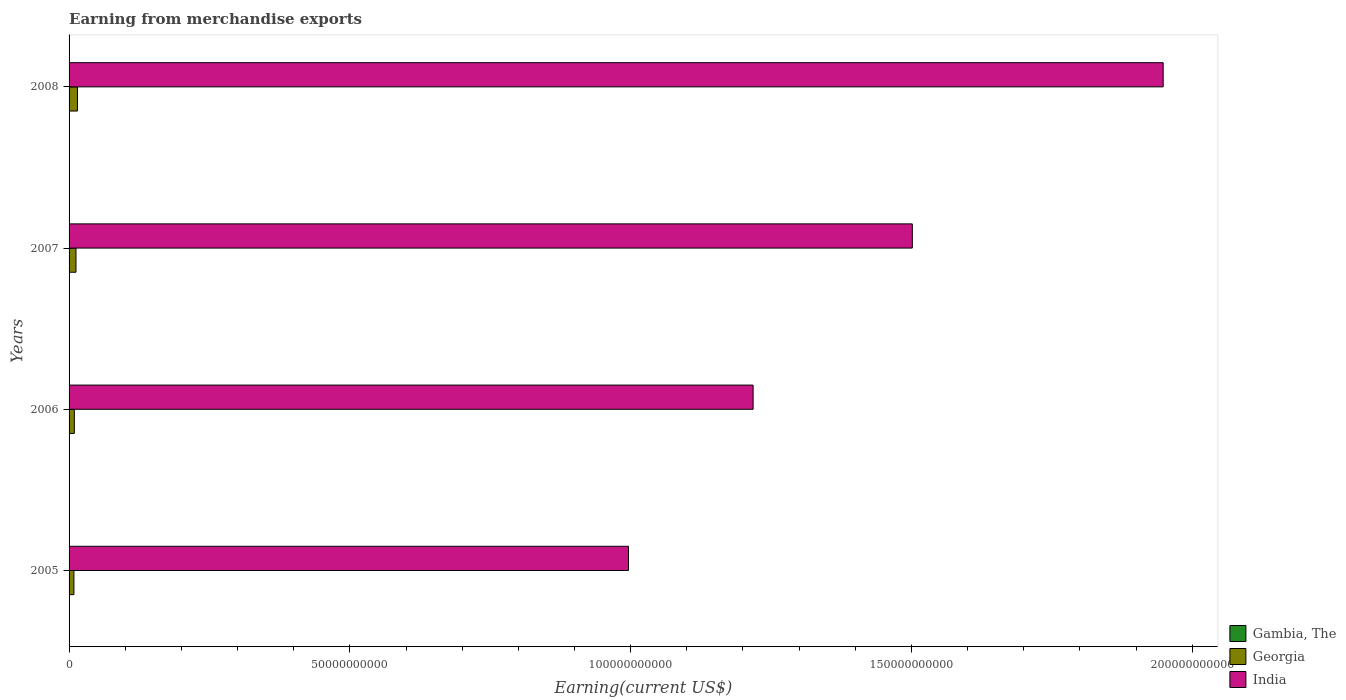Are the number of bars per tick equal to the number of legend labels?
Give a very brief answer. Yes. What is the label of the 1st group of bars from the top?
Ensure brevity in your answer.  2008. What is the amount earned from merchandise exports in India in 2006?
Provide a succinct answer. 1.22e+11. Across all years, what is the maximum amount earned from merchandise exports in Georgia?
Ensure brevity in your answer.  1.50e+09. Across all years, what is the minimum amount earned from merchandise exports in India?
Make the answer very short. 9.96e+1. What is the total amount earned from merchandise exports in Gambia, The in the graph?
Make the answer very short. 4.59e+07. What is the difference between the amount earned from merchandise exports in India in 2005 and that in 2007?
Your response must be concise. -5.05e+1. What is the difference between the amount earned from merchandise exports in Gambia, The in 2008 and the amount earned from merchandise exports in Georgia in 2007?
Make the answer very short. -1.22e+09. What is the average amount earned from merchandise exports in India per year?
Offer a very short reply. 1.42e+11. In the year 2008, what is the difference between the amount earned from merchandise exports in India and amount earned from merchandise exports in Gambia, The?
Offer a very short reply. 1.95e+11. In how many years, is the amount earned from merchandise exports in Georgia greater than 190000000000 US$?
Your response must be concise. 0. What is the ratio of the amount earned from merchandise exports in India in 2005 to that in 2007?
Keep it short and to the point. 0.66. What is the difference between the highest and the second highest amount earned from merchandise exports in Georgia?
Your answer should be compact. 2.63e+08. What is the difference between the highest and the lowest amount earned from merchandise exports in Gambia, The?
Ensure brevity in your answer.  6.21e+06. Is the sum of the amount earned from merchandise exports in India in 2007 and 2008 greater than the maximum amount earned from merchandise exports in Georgia across all years?
Offer a very short reply. Yes. What does the 3rd bar from the top in 2006 represents?
Your answer should be compact. Gambia, The. What does the 3rd bar from the bottom in 2005 represents?
Provide a succinct answer. India. How many bars are there?
Provide a succinct answer. 12. How many years are there in the graph?
Provide a succinct answer. 4. Are the values on the major ticks of X-axis written in scientific E-notation?
Make the answer very short. No. Where does the legend appear in the graph?
Ensure brevity in your answer.  Bottom right. How many legend labels are there?
Provide a succinct answer. 3. What is the title of the graph?
Keep it short and to the point. Earning from merchandise exports. What is the label or title of the X-axis?
Keep it short and to the point. Earning(current US$). What is the label or title of the Y-axis?
Give a very brief answer. Years. What is the Earning(current US$) of Gambia, The in 2005?
Your answer should be compact. 7.46e+06. What is the Earning(current US$) of Georgia in 2005?
Your answer should be compact. 8.65e+08. What is the Earning(current US$) of India in 2005?
Ensure brevity in your answer.  9.96e+1. What is the Earning(current US$) in Gambia, The in 2006?
Make the answer very short. 1.15e+07. What is the Earning(current US$) of Georgia in 2006?
Your answer should be compact. 9.36e+08. What is the Earning(current US$) in India in 2006?
Ensure brevity in your answer.  1.22e+11. What is the Earning(current US$) of Gambia, The in 2007?
Provide a succinct answer. 1.33e+07. What is the Earning(current US$) of Georgia in 2007?
Your answer should be very brief. 1.23e+09. What is the Earning(current US$) of India in 2007?
Your response must be concise. 1.50e+11. What is the Earning(current US$) of Gambia, The in 2008?
Make the answer very short. 1.37e+07. What is the Earning(current US$) in Georgia in 2008?
Offer a very short reply. 1.50e+09. What is the Earning(current US$) of India in 2008?
Offer a very short reply. 1.95e+11. Across all years, what is the maximum Earning(current US$) of Gambia, The?
Your response must be concise. 1.37e+07. Across all years, what is the maximum Earning(current US$) in Georgia?
Give a very brief answer. 1.50e+09. Across all years, what is the maximum Earning(current US$) in India?
Your answer should be compact. 1.95e+11. Across all years, what is the minimum Earning(current US$) in Gambia, The?
Your response must be concise. 7.46e+06. Across all years, what is the minimum Earning(current US$) of Georgia?
Make the answer very short. 8.65e+08. Across all years, what is the minimum Earning(current US$) of India?
Provide a short and direct response. 9.96e+1. What is the total Earning(current US$) of Gambia, The in the graph?
Keep it short and to the point. 4.59e+07. What is the total Earning(current US$) in Georgia in the graph?
Give a very brief answer. 4.53e+09. What is the total Earning(current US$) of India in the graph?
Your answer should be very brief. 5.66e+11. What is the difference between the Earning(current US$) in Gambia, The in 2005 and that in 2006?
Your answer should be compact. -4.00e+06. What is the difference between the Earning(current US$) in Georgia in 2005 and that in 2006?
Ensure brevity in your answer.  -7.12e+07. What is the difference between the Earning(current US$) of India in 2005 and that in 2006?
Your answer should be compact. -2.22e+1. What is the difference between the Earning(current US$) of Gambia, The in 2005 and that in 2007?
Make the answer very short. -5.87e+06. What is the difference between the Earning(current US$) in Georgia in 2005 and that in 2007?
Provide a succinct answer. -3.67e+08. What is the difference between the Earning(current US$) of India in 2005 and that in 2007?
Your response must be concise. -5.05e+1. What is the difference between the Earning(current US$) in Gambia, The in 2005 and that in 2008?
Keep it short and to the point. -6.21e+06. What is the difference between the Earning(current US$) in Georgia in 2005 and that in 2008?
Keep it short and to the point. -6.30e+08. What is the difference between the Earning(current US$) of India in 2005 and that in 2008?
Ensure brevity in your answer.  -9.52e+1. What is the difference between the Earning(current US$) of Gambia, The in 2006 and that in 2007?
Make the answer very short. -1.87e+06. What is the difference between the Earning(current US$) of Georgia in 2006 and that in 2007?
Your response must be concise. -2.96e+08. What is the difference between the Earning(current US$) of India in 2006 and that in 2007?
Offer a very short reply. -2.84e+1. What is the difference between the Earning(current US$) in Gambia, The in 2006 and that in 2008?
Your answer should be very brief. -2.21e+06. What is the difference between the Earning(current US$) in Georgia in 2006 and that in 2008?
Give a very brief answer. -5.59e+08. What is the difference between the Earning(current US$) in India in 2006 and that in 2008?
Make the answer very short. -7.30e+1. What is the difference between the Earning(current US$) of Gambia, The in 2007 and that in 2008?
Give a very brief answer. -3.33e+05. What is the difference between the Earning(current US$) in Georgia in 2007 and that in 2008?
Your answer should be very brief. -2.63e+08. What is the difference between the Earning(current US$) in India in 2007 and that in 2008?
Provide a short and direct response. -4.47e+1. What is the difference between the Earning(current US$) in Gambia, The in 2005 and the Earning(current US$) in Georgia in 2006?
Offer a terse response. -9.29e+08. What is the difference between the Earning(current US$) in Gambia, The in 2005 and the Earning(current US$) in India in 2006?
Your answer should be compact. -1.22e+11. What is the difference between the Earning(current US$) in Georgia in 2005 and the Earning(current US$) in India in 2006?
Offer a terse response. -1.21e+11. What is the difference between the Earning(current US$) in Gambia, The in 2005 and the Earning(current US$) in Georgia in 2007?
Offer a very short reply. -1.22e+09. What is the difference between the Earning(current US$) in Gambia, The in 2005 and the Earning(current US$) in India in 2007?
Offer a terse response. -1.50e+11. What is the difference between the Earning(current US$) in Georgia in 2005 and the Earning(current US$) in India in 2007?
Provide a short and direct response. -1.49e+11. What is the difference between the Earning(current US$) in Gambia, The in 2005 and the Earning(current US$) in Georgia in 2008?
Provide a succinct answer. -1.49e+09. What is the difference between the Earning(current US$) of Gambia, The in 2005 and the Earning(current US$) of India in 2008?
Your answer should be compact. -1.95e+11. What is the difference between the Earning(current US$) in Georgia in 2005 and the Earning(current US$) in India in 2008?
Provide a short and direct response. -1.94e+11. What is the difference between the Earning(current US$) of Gambia, The in 2006 and the Earning(current US$) of Georgia in 2007?
Your answer should be compact. -1.22e+09. What is the difference between the Earning(current US$) of Gambia, The in 2006 and the Earning(current US$) of India in 2007?
Provide a succinct answer. -1.50e+11. What is the difference between the Earning(current US$) of Georgia in 2006 and the Earning(current US$) of India in 2007?
Your response must be concise. -1.49e+11. What is the difference between the Earning(current US$) in Gambia, The in 2006 and the Earning(current US$) in Georgia in 2008?
Keep it short and to the point. -1.48e+09. What is the difference between the Earning(current US$) of Gambia, The in 2006 and the Earning(current US$) of India in 2008?
Give a very brief answer. -1.95e+11. What is the difference between the Earning(current US$) in Georgia in 2006 and the Earning(current US$) in India in 2008?
Provide a succinct answer. -1.94e+11. What is the difference between the Earning(current US$) of Gambia, The in 2007 and the Earning(current US$) of Georgia in 2008?
Provide a short and direct response. -1.48e+09. What is the difference between the Earning(current US$) in Gambia, The in 2007 and the Earning(current US$) in India in 2008?
Offer a terse response. -1.95e+11. What is the difference between the Earning(current US$) of Georgia in 2007 and the Earning(current US$) of India in 2008?
Keep it short and to the point. -1.94e+11. What is the average Earning(current US$) of Gambia, The per year?
Provide a succinct answer. 1.15e+07. What is the average Earning(current US$) in Georgia per year?
Provide a succinct answer. 1.13e+09. What is the average Earning(current US$) of India per year?
Your answer should be very brief. 1.42e+11. In the year 2005, what is the difference between the Earning(current US$) of Gambia, The and Earning(current US$) of Georgia?
Offer a very short reply. -8.58e+08. In the year 2005, what is the difference between the Earning(current US$) in Gambia, The and Earning(current US$) in India?
Provide a succinct answer. -9.96e+1. In the year 2005, what is the difference between the Earning(current US$) of Georgia and Earning(current US$) of India?
Provide a short and direct response. -9.88e+1. In the year 2006, what is the difference between the Earning(current US$) in Gambia, The and Earning(current US$) in Georgia?
Offer a very short reply. -9.25e+08. In the year 2006, what is the difference between the Earning(current US$) of Gambia, The and Earning(current US$) of India?
Ensure brevity in your answer.  -1.22e+11. In the year 2006, what is the difference between the Earning(current US$) in Georgia and Earning(current US$) in India?
Your answer should be compact. -1.21e+11. In the year 2007, what is the difference between the Earning(current US$) of Gambia, The and Earning(current US$) of Georgia?
Keep it short and to the point. -1.22e+09. In the year 2007, what is the difference between the Earning(current US$) in Gambia, The and Earning(current US$) in India?
Your answer should be compact. -1.50e+11. In the year 2007, what is the difference between the Earning(current US$) in Georgia and Earning(current US$) in India?
Provide a short and direct response. -1.49e+11. In the year 2008, what is the difference between the Earning(current US$) in Gambia, The and Earning(current US$) in Georgia?
Make the answer very short. -1.48e+09. In the year 2008, what is the difference between the Earning(current US$) in Gambia, The and Earning(current US$) in India?
Ensure brevity in your answer.  -1.95e+11. In the year 2008, what is the difference between the Earning(current US$) of Georgia and Earning(current US$) of India?
Your response must be concise. -1.93e+11. What is the ratio of the Earning(current US$) of Gambia, The in 2005 to that in 2006?
Your answer should be very brief. 0.65. What is the ratio of the Earning(current US$) in Georgia in 2005 to that in 2006?
Ensure brevity in your answer.  0.92. What is the ratio of the Earning(current US$) in India in 2005 to that in 2006?
Make the answer very short. 0.82. What is the ratio of the Earning(current US$) of Gambia, The in 2005 to that in 2007?
Keep it short and to the point. 0.56. What is the ratio of the Earning(current US$) in Georgia in 2005 to that in 2007?
Provide a succinct answer. 0.7. What is the ratio of the Earning(current US$) in India in 2005 to that in 2007?
Provide a succinct answer. 0.66. What is the ratio of the Earning(current US$) in Gambia, The in 2005 to that in 2008?
Your answer should be very brief. 0.55. What is the ratio of the Earning(current US$) in Georgia in 2005 to that in 2008?
Your response must be concise. 0.58. What is the ratio of the Earning(current US$) of India in 2005 to that in 2008?
Give a very brief answer. 0.51. What is the ratio of the Earning(current US$) in Gambia, The in 2006 to that in 2007?
Keep it short and to the point. 0.86. What is the ratio of the Earning(current US$) in Georgia in 2006 to that in 2007?
Give a very brief answer. 0.76. What is the ratio of the Earning(current US$) in India in 2006 to that in 2007?
Your answer should be very brief. 0.81. What is the ratio of the Earning(current US$) in Gambia, The in 2006 to that in 2008?
Your response must be concise. 0.84. What is the ratio of the Earning(current US$) of Georgia in 2006 to that in 2008?
Provide a short and direct response. 0.63. What is the ratio of the Earning(current US$) of India in 2006 to that in 2008?
Provide a succinct answer. 0.63. What is the ratio of the Earning(current US$) of Gambia, The in 2007 to that in 2008?
Provide a short and direct response. 0.98. What is the ratio of the Earning(current US$) in Georgia in 2007 to that in 2008?
Give a very brief answer. 0.82. What is the ratio of the Earning(current US$) in India in 2007 to that in 2008?
Make the answer very short. 0.77. What is the difference between the highest and the second highest Earning(current US$) of Gambia, The?
Give a very brief answer. 3.33e+05. What is the difference between the highest and the second highest Earning(current US$) of Georgia?
Make the answer very short. 2.63e+08. What is the difference between the highest and the second highest Earning(current US$) in India?
Offer a very short reply. 4.47e+1. What is the difference between the highest and the lowest Earning(current US$) of Gambia, The?
Offer a very short reply. 6.21e+06. What is the difference between the highest and the lowest Earning(current US$) of Georgia?
Your answer should be compact. 6.30e+08. What is the difference between the highest and the lowest Earning(current US$) of India?
Keep it short and to the point. 9.52e+1. 